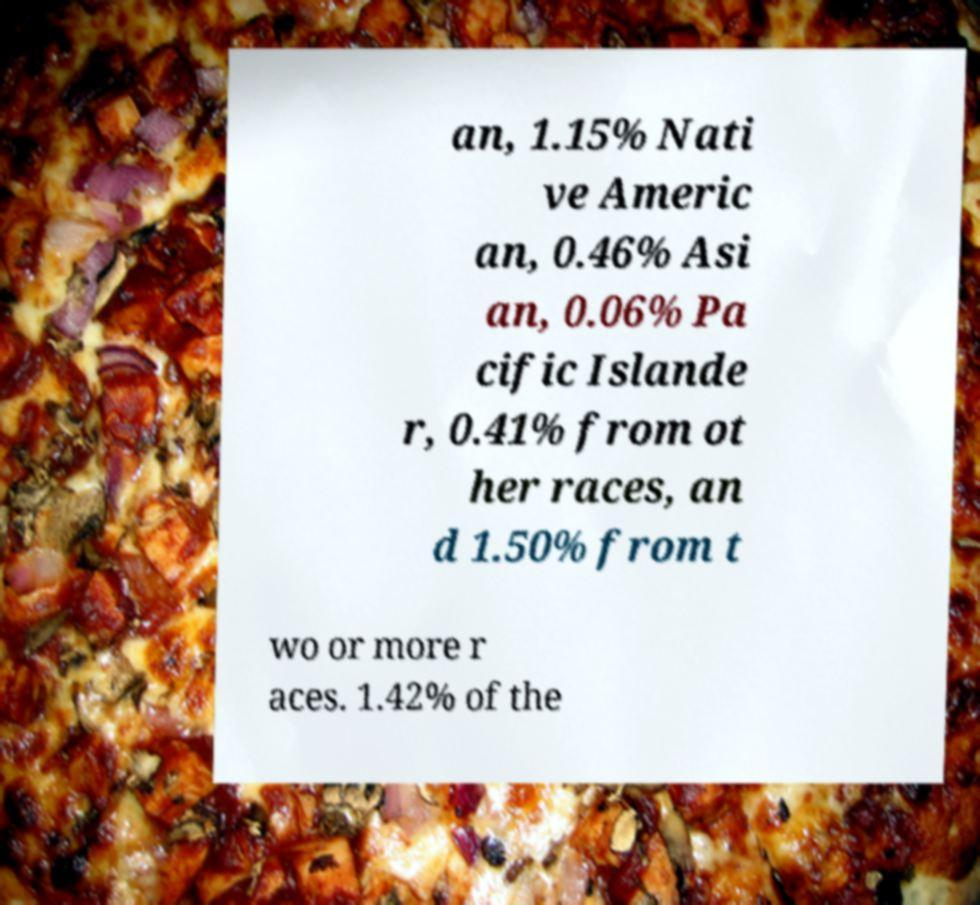Could you assist in decoding the text presented in this image and type it out clearly? an, 1.15% Nati ve Americ an, 0.46% Asi an, 0.06% Pa cific Islande r, 0.41% from ot her races, an d 1.50% from t wo or more r aces. 1.42% of the 